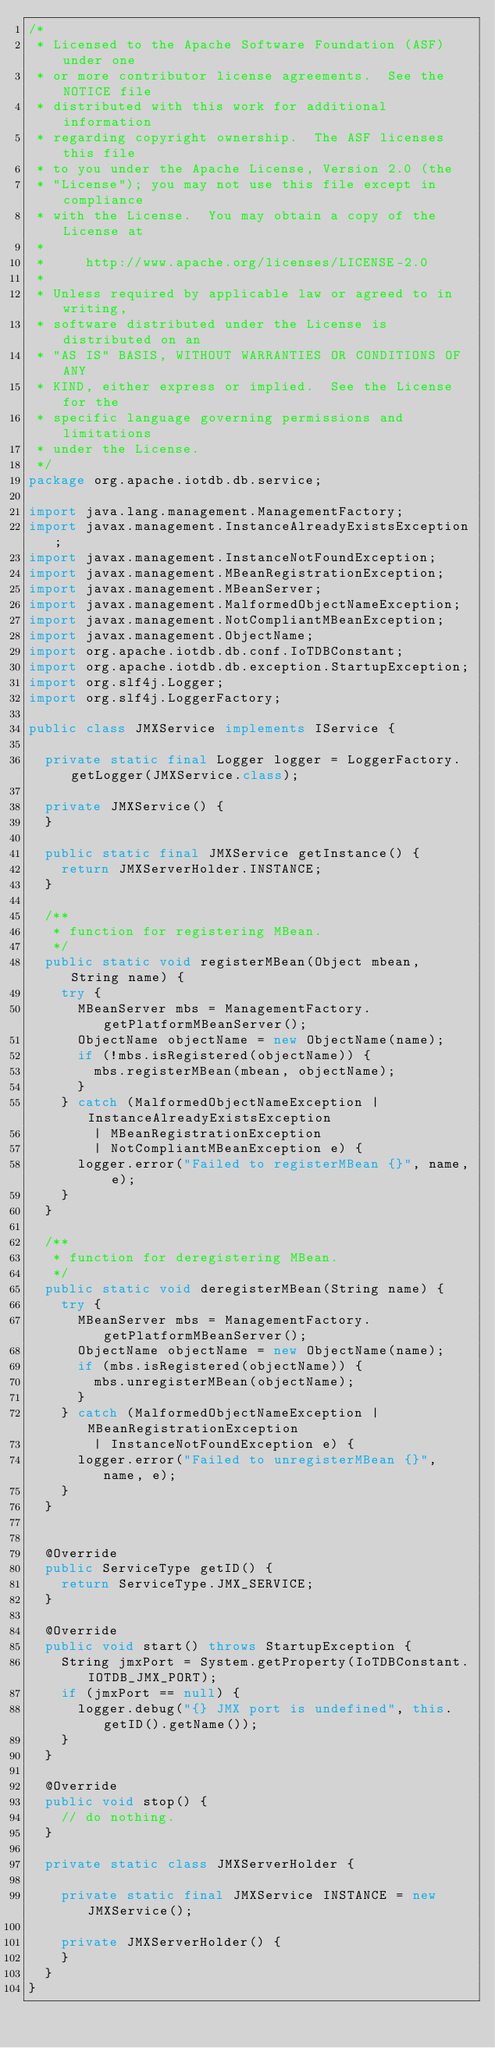<code> <loc_0><loc_0><loc_500><loc_500><_Java_>/*
 * Licensed to the Apache Software Foundation (ASF) under one
 * or more contributor license agreements.  See the NOTICE file
 * distributed with this work for additional information
 * regarding copyright ownership.  The ASF licenses this file
 * to you under the Apache License, Version 2.0 (the
 * "License"); you may not use this file except in compliance
 * with the License.  You may obtain a copy of the License at
 *
 *     http://www.apache.org/licenses/LICENSE-2.0
 *
 * Unless required by applicable law or agreed to in writing,
 * software distributed under the License is distributed on an
 * "AS IS" BASIS, WITHOUT WARRANTIES OR CONDITIONS OF ANY
 * KIND, either express or implied.  See the License for the
 * specific language governing permissions and limitations
 * under the License.
 */
package org.apache.iotdb.db.service;

import java.lang.management.ManagementFactory;
import javax.management.InstanceAlreadyExistsException;
import javax.management.InstanceNotFoundException;
import javax.management.MBeanRegistrationException;
import javax.management.MBeanServer;
import javax.management.MalformedObjectNameException;
import javax.management.NotCompliantMBeanException;
import javax.management.ObjectName;
import org.apache.iotdb.db.conf.IoTDBConstant;
import org.apache.iotdb.db.exception.StartupException;
import org.slf4j.Logger;
import org.slf4j.LoggerFactory;

public class JMXService implements IService {

  private static final Logger logger = LoggerFactory.getLogger(JMXService.class);

  private JMXService() {
  }

  public static final JMXService getInstance() {
    return JMXServerHolder.INSTANCE;
  }

  /**
   * function for registering MBean.
   */
  public static void registerMBean(Object mbean, String name) {
    try {
      MBeanServer mbs = ManagementFactory.getPlatformMBeanServer();
      ObjectName objectName = new ObjectName(name);
      if (!mbs.isRegistered(objectName)) {
        mbs.registerMBean(mbean, objectName);
      }
    } catch (MalformedObjectNameException | InstanceAlreadyExistsException
        | MBeanRegistrationException
        | NotCompliantMBeanException e) {
      logger.error("Failed to registerMBean {}", name, e);
    }
  }

  /**
   * function for deregistering MBean.
   */
  public static void deregisterMBean(String name) {
    try {
      MBeanServer mbs = ManagementFactory.getPlatformMBeanServer();
      ObjectName objectName = new ObjectName(name);
      if (mbs.isRegistered(objectName)) {
        mbs.unregisterMBean(objectName);
      }
    } catch (MalformedObjectNameException | MBeanRegistrationException
        | InstanceNotFoundException e) {
      logger.error("Failed to unregisterMBean {}", name, e);
    }
  }


  @Override
  public ServiceType getID() {
    return ServiceType.JMX_SERVICE;
  }

  @Override
  public void start() throws StartupException {
    String jmxPort = System.getProperty(IoTDBConstant.IOTDB_JMX_PORT);
    if (jmxPort == null) {
      logger.debug("{} JMX port is undefined", this.getID().getName());
    }
  }

  @Override
  public void stop() {
    // do nothing.
  }

  private static class JMXServerHolder {

    private static final JMXService INSTANCE = new JMXService();

    private JMXServerHolder() {
    }
  }
}
</code> 